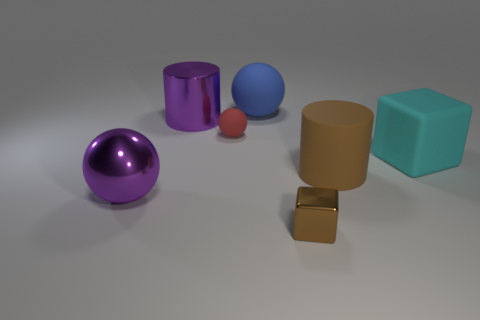Add 3 rubber cubes. How many objects exist? 10 Subtract all cylinders. How many objects are left? 5 Subtract all small brown matte blocks. Subtract all rubber things. How many objects are left? 3 Add 2 large blue matte objects. How many large blue matte objects are left? 3 Add 2 cylinders. How many cylinders exist? 4 Subtract 0 blue cubes. How many objects are left? 7 